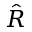<formula> <loc_0><loc_0><loc_500><loc_500>\hat { R }</formula> 